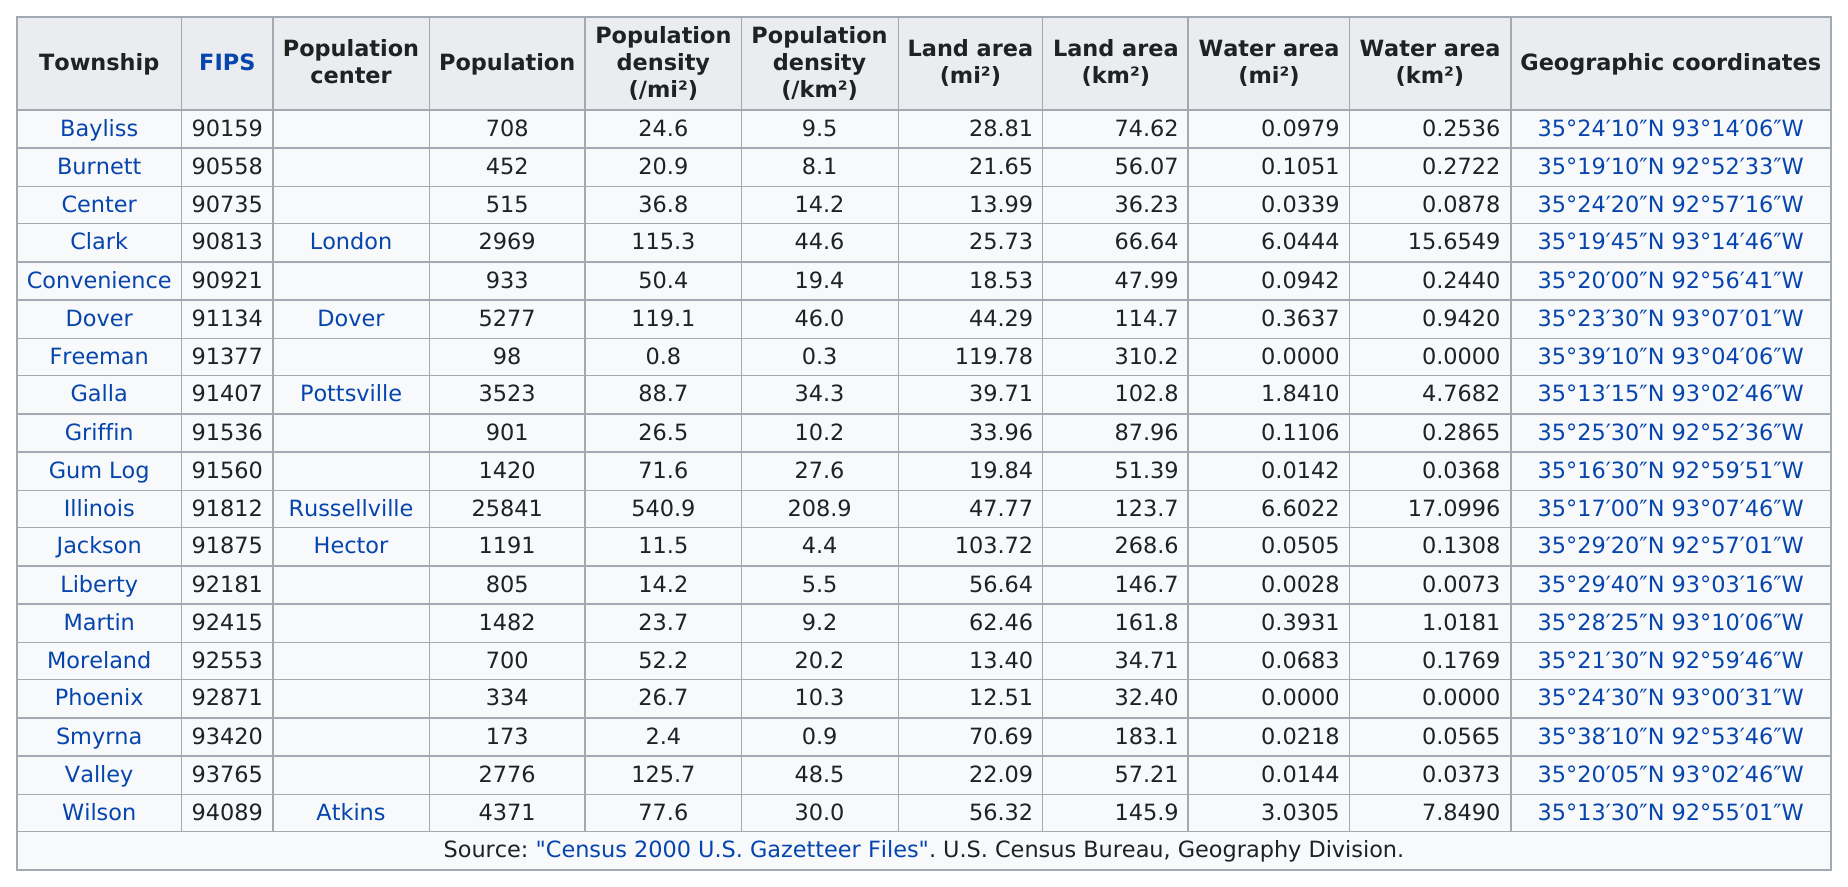Outline some significant characteristics in this image. There are 19 townships in Pope County. I will strive to fulfill my duties and responsibilities with honesty, integrity, and transparency, while seeking to uphold the laws and principles of our great nation. I will remain steadfast in my commitment to serve and protect all citizens, and will work tirelessly to promote the well-being and prosperity of our nation. Freeman Township has the least amount of water area in miles out of all of the townships. In Pope County, Arkansas, the township with the smallest population is Freeman Township. The total population of Burnett Township is 452. 